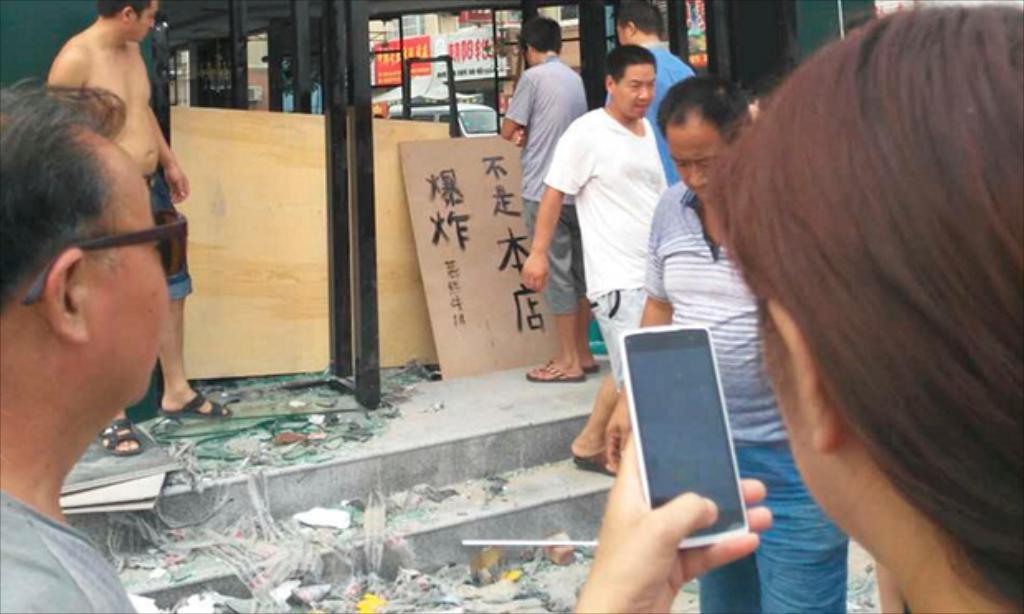How would you summarize this image in a sentence or two? This image is taken outdoors. At the bottom of the image there are a few stairs. There are many objects on the stairs. On the right side of the image a person is holding a mobile phone in the hand and two men are walking and two men are standing on the floor. On the left side of the image two men are standing. In the background there are two wooden boards and there is a text on the board. There is a building and there are two boards with text on them. There is a vehicle and there is a tent. 